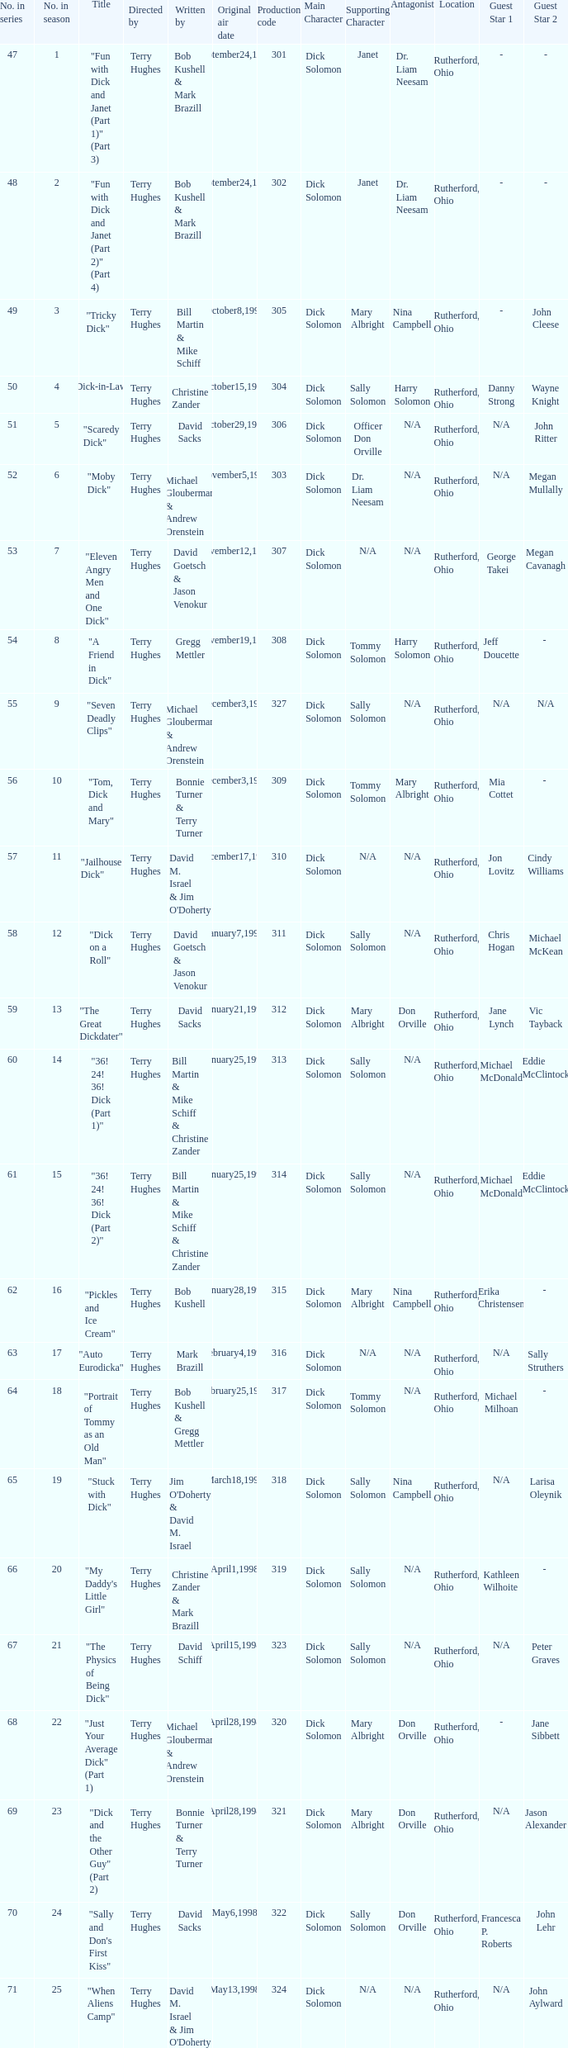What is the title of episode 10? "Tom, Dick and Mary". 